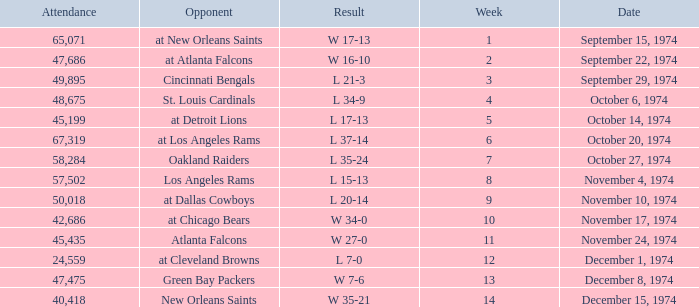What was the result before week 13 when they played the Oakland Raiders? L 35-24. Could you parse the entire table as a dict? {'header': ['Attendance', 'Opponent', 'Result', 'Week', 'Date'], 'rows': [['65,071', 'at New Orleans Saints', 'W 17-13', '1', 'September 15, 1974'], ['47,686', 'at Atlanta Falcons', 'W 16-10', '2', 'September 22, 1974'], ['49,895', 'Cincinnati Bengals', 'L 21-3', '3', 'September 29, 1974'], ['48,675', 'St. Louis Cardinals', 'L 34-9', '4', 'October 6, 1974'], ['45,199', 'at Detroit Lions', 'L 17-13', '5', 'October 14, 1974'], ['67,319', 'at Los Angeles Rams', 'L 37-14', '6', 'October 20, 1974'], ['58,284', 'Oakland Raiders', 'L 35-24', '7', 'October 27, 1974'], ['57,502', 'Los Angeles Rams', 'L 15-13', '8', 'November 4, 1974'], ['50,018', 'at Dallas Cowboys', 'L 20-14', '9', 'November 10, 1974'], ['42,686', 'at Chicago Bears', 'W 34-0', '10', 'November 17, 1974'], ['45,435', 'Atlanta Falcons', 'W 27-0', '11', 'November 24, 1974'], ['24,559', 'at Cleveland Browns', 'L 7-0', '12', 'December 1, 1974'], ['47,475', 'Green Bay Packers', 'W 7-6', '13', 'December 8, 1974'], ['40,418', 'New Orleans Saints', 'W 35-21', '14', 'December 15, 1974']]} 